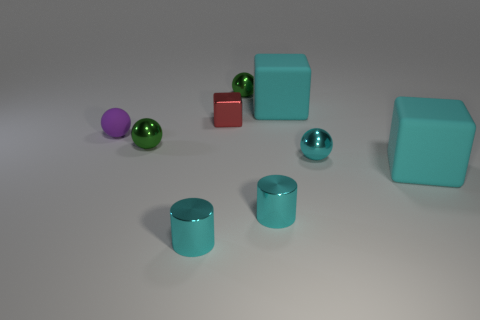Does the green metal thing on the right side of the red metallic object have the same shape as the small green thing in front of the small purple thing?
Provide a succinct answer. Yes. There is a metallic sphere that is to the left of the red thing; is it the same size as the red metallic object?
Your response must be concise. Yes. Do the tiny cylinder on the right side of the red thing and the big object that is in front of the purple matte thing have the same material?
Your answer should be very brief. No. Is there a cyan cube of the same size as the purple rubber sphere?
Provide a short and direct response. No. What shape is the small cyan shiny thing behind the cyan rubber object in front of the matte cube behind the tiny cyan metal sphere?
Provide a short and direct response. Sphere. Are there more small cyan cylinders to the right of the metallic cube than red balls?
Give a very brief answer. Yes. Are there any cyan metal things that have the same shape as the tiny purple matte object?
Make the answer very short. Yes. Does the small red block have the same material as the big cyan thing behind the small rubber thing?
Your answer should be very brief. No. What is the color of the tiny cube?
Provide a succinct answer. Red. What number of spheres are to the right of the green sphere that is behind the purple object that is left of the red metal block?
Offer a very short reply. 1. 